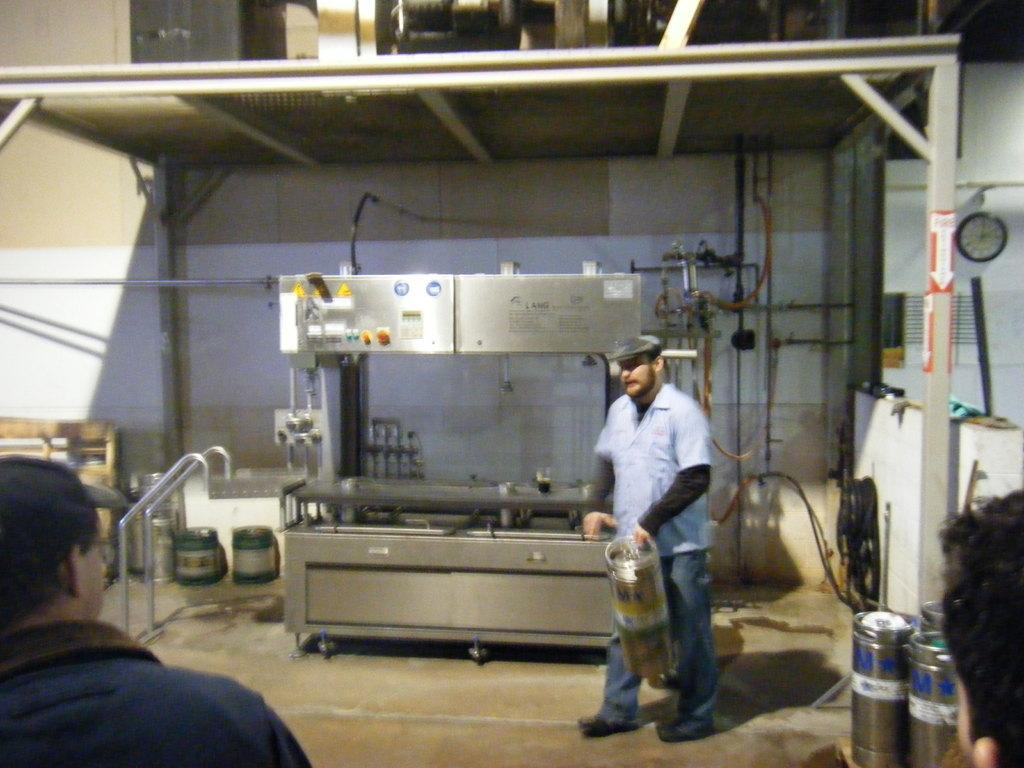What is the person holding in the image? The person is holding something in the image, but the specific object is not mentioned in the facts. What can be seen in the background of the image? There is a machine in the background of the image. How many people are present in the image? There are other people in the image, but the exact number is not mentioned in the facts. What other things can be seen in the image? There are other things in the image, but their nature is not specified in the facts. What is on the wall in the image? There is a clock on the wall in the image. What is the person's tendency to hope while rubbing the object in the image? There is no mention of the person's hope or rubbing in the image, as the facts only state that the person is holding something. 